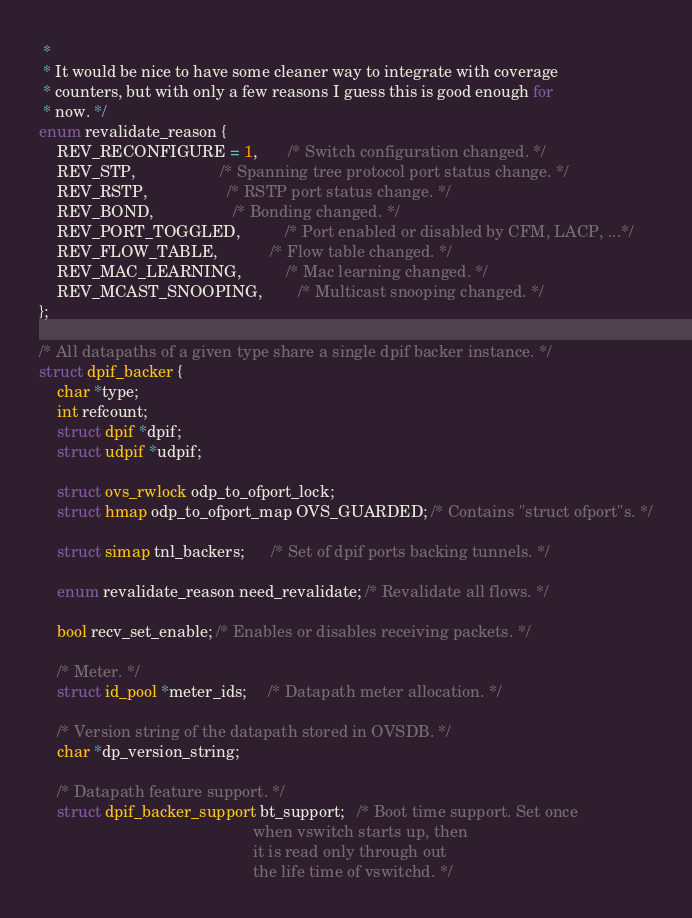<code> <loc_0><loc_0><loc_500><loc_500><_C_> *
 * It would be nice to have some cleaner way to integrate with coverage
 * counters, but with only a few reasons I guess this is good enough for
 * now. */
enum revalidate_reason {
    REV_RECONFIGURE = 1,       /* Switch configuration changed. */
    REV_STP,                   /* Spanning tree protocol port status change. */
    REV_RSTP,                  /* RSTP port status change. */
    REV_BOND,                  /* Bonding changed. */
    REV_PORT_TOGGLED,          /* Port enabled or disabled by CFM, LACP, ...*/
    REV_FLOW_TABLE,            /* Flow table changed. */
    REV_MAC_LEARNING,          /* Mac learning changed. */
    REV_MCAST_SNOOPING,        /* Multicast snooping changed. */
};

/* All datapaths of a given type share a single dpif backer instance. */
struct dpif_backer {
    char *type;
    int refcount;
    struct dpif *dpif;
    struct udpif *udpif;

    struct ovs_rwlock odp_to_ofport_lock;
    struct hmap odp_to_ofport_map OVS_GUARDED; /* Contains "struct ofport"s. */

    struct simap tnl_backers;      /* Set of dpif ports backing tunnels. */

    enum revalidate_reason need_revalidate; /* Revalidate all flows. */

    bool recv_set_enable; /* Enables or disables receiving packets. */

    /* Meter. */
    struct id_pool *meter_ids;     /* Datapath meter allocation. */

    /* Version string of the datapath stored in OVSDB. */
    char *dp_version_string;

    /* Datapath feature support. */
    struct dpif_backer_support bt_support;   /* Boot time support. Set once
                                                when vswitch starts up, then
                                                it is read only through out
                                                the life time of vswitchd. */</code> 